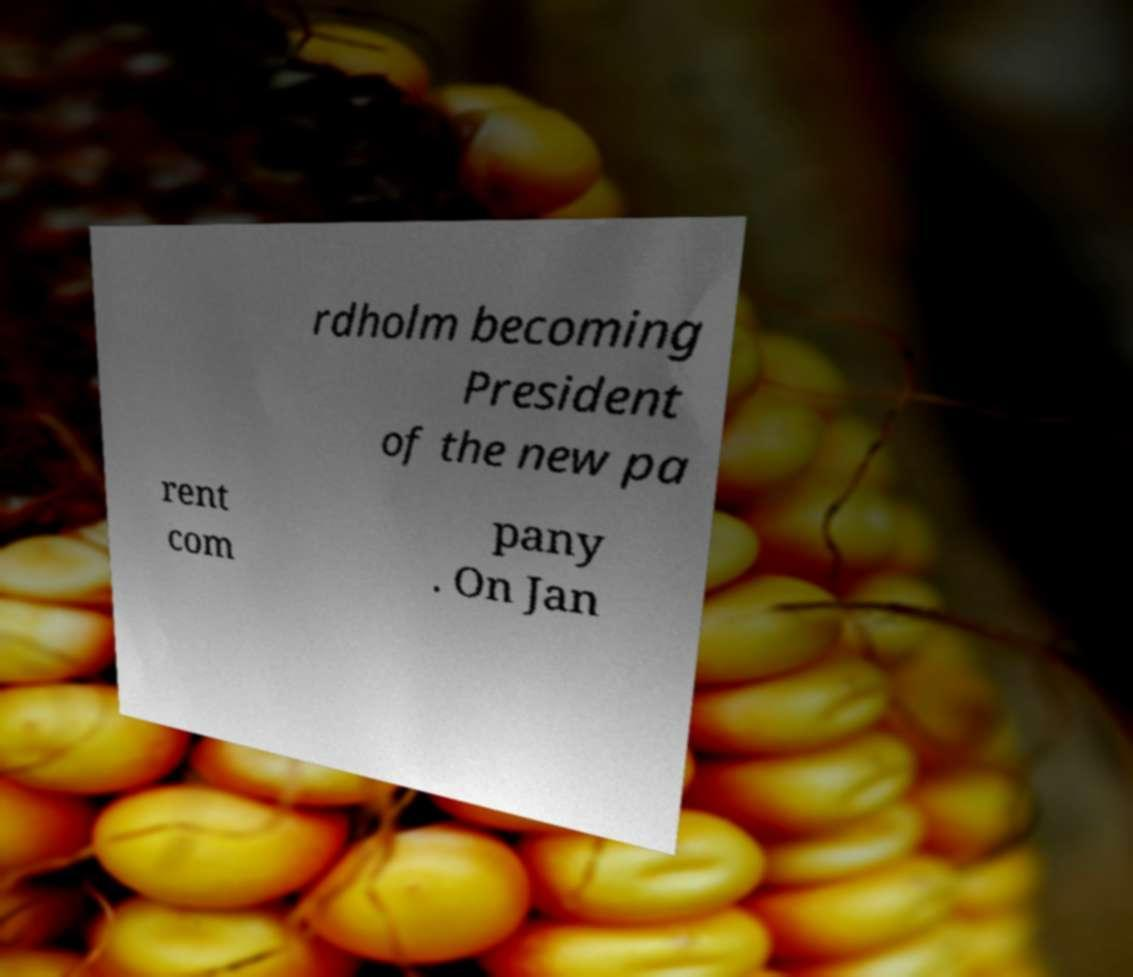I need the written content from this picture converted into text. Can you do that? rdholm becoming President of the new pa rent com pany . On Jan 